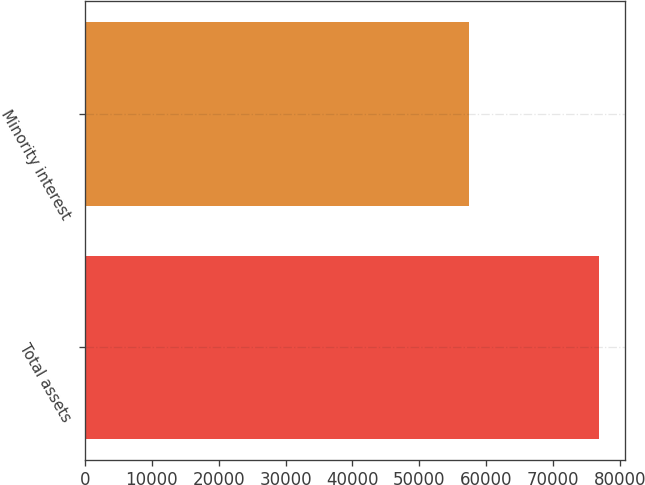Convert chart to OTSL. <chart><loc_0><loc_0><loc_500><loc_500><bar_chart><fcel>Total assets<fcel>Minority interest<nl><fcel>76881<fcel>57483<nl></chart> 